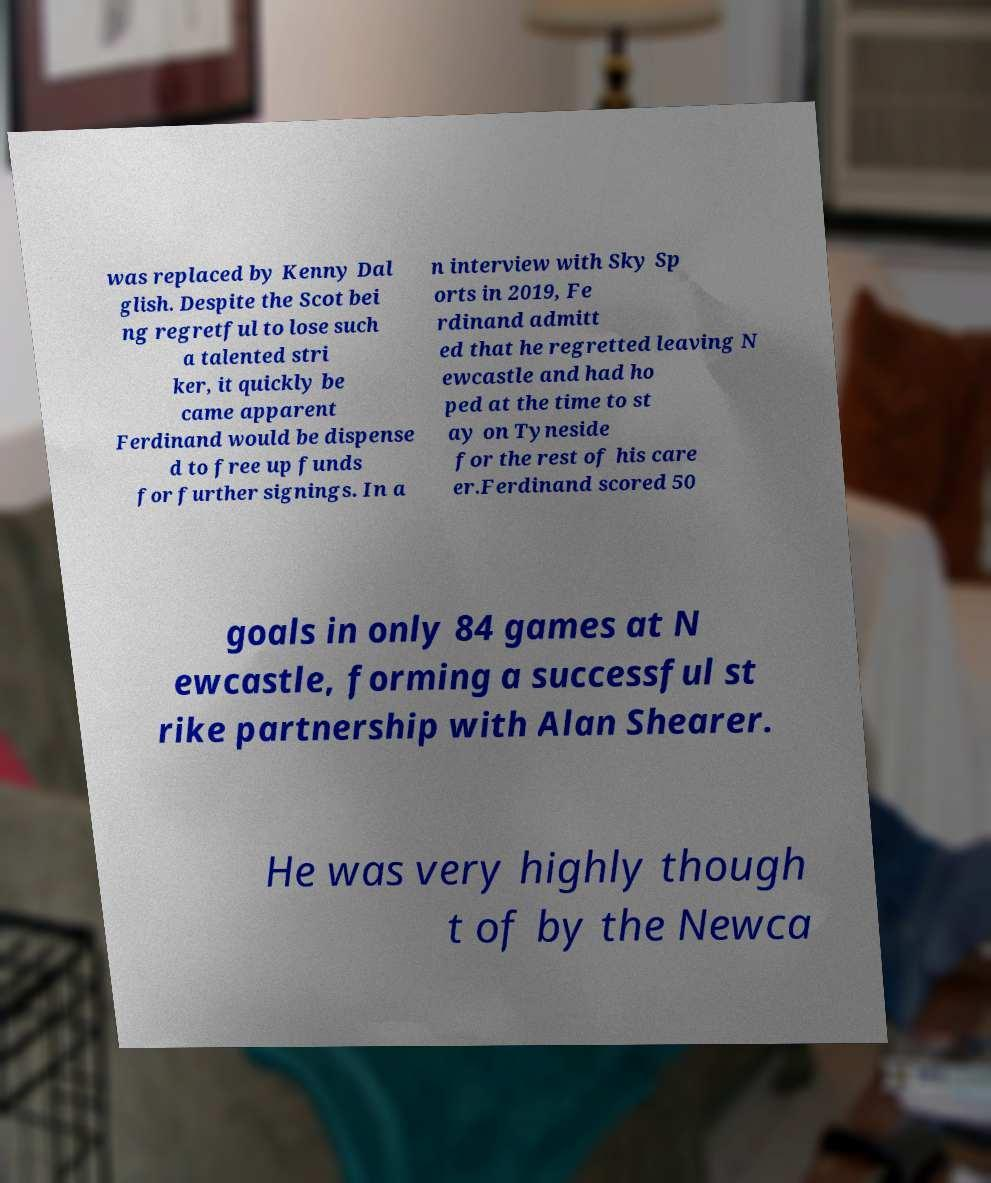Could you assist in decoding the text presented in this image and type it out clearly? was replaced by Kenny Dal glish. Despite the Scot bei ng regretful to lose such a talented stri ker, it quickly be came apparent Ferdinand would be dispense d to free up funds for further signings. In a n interview with Sky Sp orts in 2019, Fe rdinand admitt ed that he regretted leaving N ewcastle and had ho ped at the time to st ay on Tyneside for the rest of his care er.Ferdinand scored 50 goals in only 84 games at N ewcastle, forming a successful st rike partnership with Alan Shearer. He was very highly though t of by the Newca 